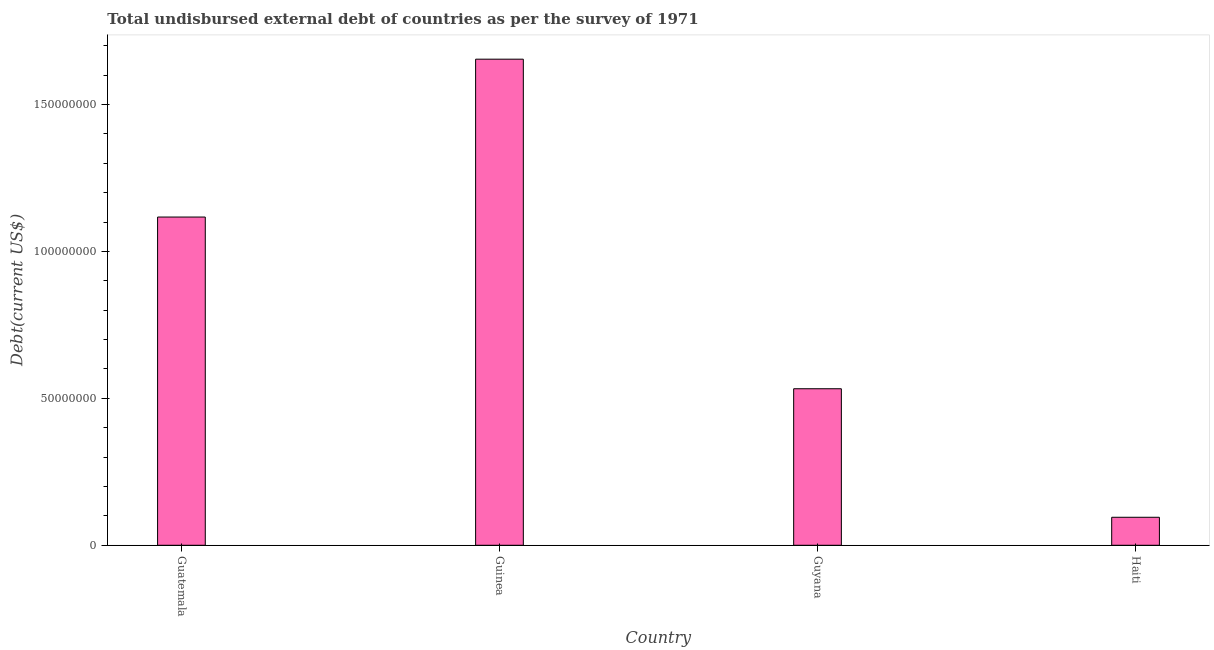Does the graph contain any zero values?
Offer a terse response. No. What is the title of the graph?
Ensure brevity in your answer.  Total undisbursed external debt of countries as per the survey of 1971. What is the label or title of the Y-axis?
Ensure brevity in your answer.  Debt(current US$). What is the total debt in Guyana?
Keep it short and to the point. 5.33e+07. Across all countries, what is the maximum total debt?
Your answer should be compact. 1.65e+08. Across all countries, what is the minimum total debt?
Provide a short and direct response. 9.53e+06. In which country was the total debt maximum?
Offer a terse response. Guinea. In which country was the total debt minimum?
Offer a very short reply. Haiti. What is the sum of the total debt?
Your answer should be compact. 3.40e+08. What is the difference between the total debt in Guinea and Haiti?
Provide a short and direct response. 1.56e+08. What is the average total debt per country?
Give a very brief answer. 8.50e+07. What is the median total debt?
Your answer should be compact. 8.25e+07. In how many countries, is the total debt greater than 10000000 US$?
Provide a succinct answer. 3. What is the ratio of the total debt in Guyana to that in Haiti?
Your answer should be very brief. 5.59. Is the difference between the total debt in Guyana and Haiti greater than the difference between any two countries?
Your response must be concise. No. What is the difference between the highest and the second highest total debt?
Offer a terse response. 5.37e+07. What is the difference between the highest and the lowest total debt?
Ensure brevity in your answer.  1.56e+08. In how many countries, is the total debt greater than the average total debt taken over all countries?
Provide a short and direct response. 2. How many bars are there?
Your answer should be very brief. 4. How many countries are there in the graph?
Give a very brief answer. 4. What is the difference between two consecutive major ticks on the Y-axis?
Provide a short and direct response. 5.00e+07. Are the values on the major ticks of Y-axis written in scientific E-notation?
Make the answer very short. No. What is the Debt(current US$) of Guatemala?
Ensure brevity in your answer.  1.12e+08. What is the Debt(current US$) of Guinea?
Offer a terse response. 1.65e+08. What is the Debt(current US$) of Guyana?
Ensure brevity in your answer.  5.33e+07. What is the Debt(current US$) of Haiti?
Offer a very short reply. 9.53e+06. What is the difference between the Debt(current US$) in Guatemala and Guinea?
Provide a succinct answer. -5.37e+07. What is the difference between the Debt(current US$) in Guatemala and Guyana?
Provide a succinct answer. 5.84e+07. What is the difference between the Debt(current US$) in Guatemala and Haiti?
Make the answer very short. 1.02e+08. What is the difference between the Debt(current US$) in Guinea and Guyana?
Keep it short and to the point. 1.12e+08. What is the difference between the Debt(current US$) in Guinea and Haiti?
Offer a terse response. 1.56e+08. What is the difference between the Debt(current US$) in Guyana and Haiti?
Keep it short and to the point. 4.37e+07. What is the ratio of the Debt(current US$) in Guatemala to that in Guinea?
Keep it short and to the point. 0.68. What is the ratio of the Debt(current US$) in Guatemala to that in Guyana?
Offer a terse response. 2.1. What is the ratio of the Debt(current US$) in Guatemala to that in Haiti?
Make the answer very short. 11.72. What is the ratio of the Debt(current US$) in Guinea to that in Guyana?
Provide a short and direct response. 3.1. What is the ratio of the Debt(current US$) in Guinea to that in Haiti?
Make the answer very short. 17.36. What is the ratio of the Debt(current US$) in Guyana to that in Haiti?
Your response must be concise. 5.59. 